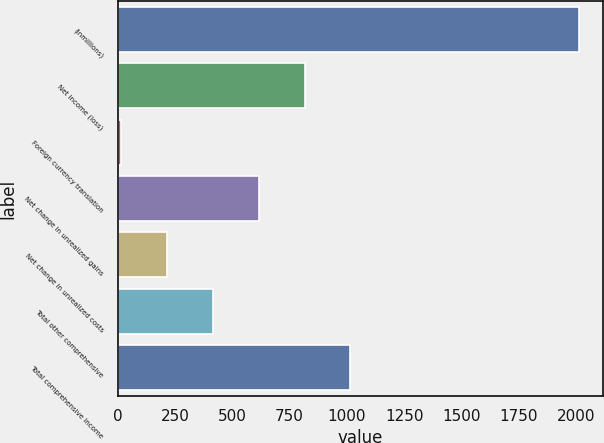<chart> <loc_0><loc_0><loc_500><loc_500><bar_chart><fcel>(inmillions)<fcel>Net income (loss)<fcel>Foreign currency translation<fcel>Net change in unrealized gains<fcel>Net change in unrealized costs<fcel>Total other comprehensive<fcel>Total comprehensive income<nl><fcel>2015<fcel>815.6<fcel>16<fcel>615.7<fcel>215.9<fcel>415.8<fcel>1015.5<nl></chart> 